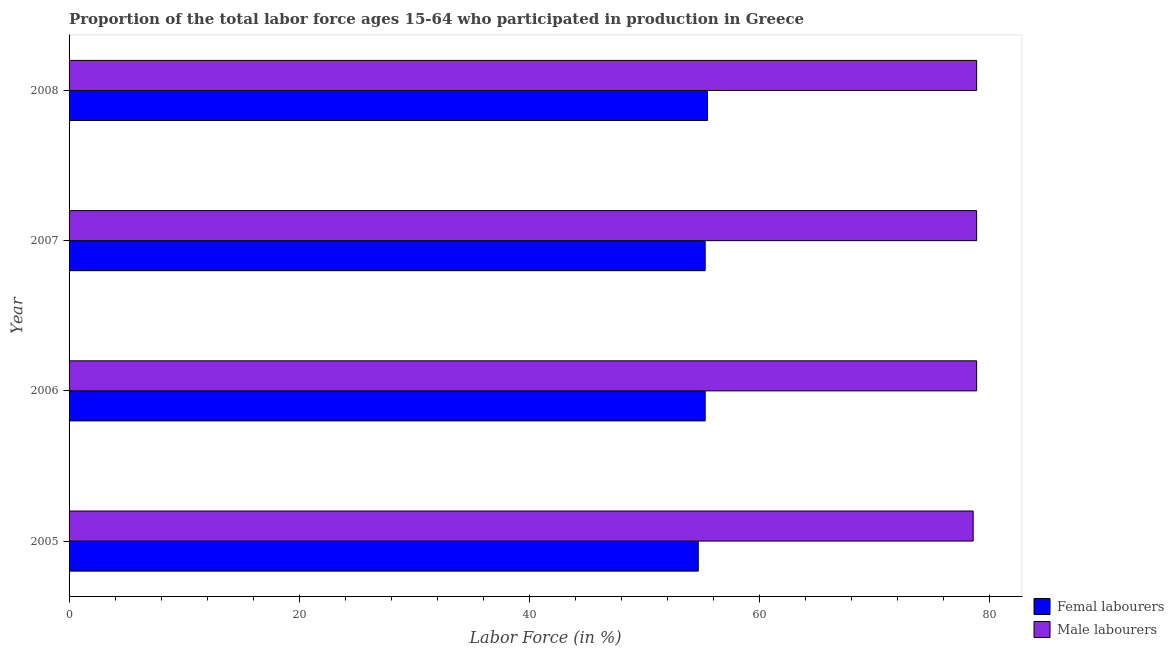How many groups of bars are there?
Offer a terse response. 4. Are the number of bars on each tick of the Y-axis equal?
Keep it short and to the point. Yes. In how many cases, is the number of bars for a given year not equal to the number of legend labels?
Provide a short and direct response. 0. What is the percentage of male labour force in 2006?
Give a very brief answer. 78.9. Across all years, what is the maximum percentage of female labor force?
Your response must be concise. 55.5. Across all years, what is the minimum percentage of male labour force?
Make the answer very short. 78.6. In which year was the percentage of female labor force maximum?
Provide a succinct answer. 2008. What is the total percentage of male labour force in the graph?
Provide a short and direct response. 315.3. What is the difference between the percentage of male labour force in 2007 and that in 2008?
Offer a terse response. 0. What is the difference between the percentage of female labor force in 2006 and the percentage of male labour force in 2008?
Your response must be concise. -23.6. What is the average percentage of male labour force per year?
Give a very brief answer. 78.83. In the year 2008, what is the difference between the percentage of male labour force and percentage of female labor force?
Keep it short and to the point. 23.4. What is the ratio of the percentage of female labor force in 2005 to that in 2007?
Your answer should be very brief. 0.99. Is the percentage of female labor force in 2005 less than that in 2006?
Your answer should be very brief. Yes. What is the difference between the highest and the lowest percentage of female labor force?
Provide a short and direct response. 0.8. In how many years, is the percentage of female labor force greater than the average percentage of female labor force taken over all years?
Your answer should be compact. 3. What does the 1st bar from the top in 2006 represents?
Offer a terse response. Male labourers. What does the 2nd bar from the bottom in 2006 represents?
Offer a very short reply. Male labourers. Are all the bars in the graph horizontal?
Your response must be concise. Yes. How many years are there in the graph?
Provide a succinct answer. 4. What is the difference between two consecutive major ticks on the X-axis?
Offer a terse response. 20. Does the graph contain grids?
Offer a very short reply. No. What is the title of the graph?
Provide a succinct answer. Proportion of the total labor force ages 15-64 who participated in production in Greece. Does "International Tourists" appear as one of the legend labels in the graph?
Provide a succinct answer. No. What is the Labor Force (in %) in Femal labourers in 2005?
Ensure brevity in your answer.  54.7. What is the Labor Force (in %) of Male labourers in 2005?
Provide a short and direct response. 78.6. What is the Labor Force (in %) in Femal labourers in 2006?
Your answer should be very brief. 55.3. What is the Labor Force (in %) in Male labourers in 2006?
Provide a succinct answer. 78.9. What is the Labor Force (in %) in Femal labourers in 2007?
Give a very brief answer. 55.3. What is the Labor Force (in %) in Male labourers in 2007?
Your answer should be very brief. 78.9. What is the Labor Force (in %) in Femal labourers in 2008?
Make the answer very short. 55.5. What is the Labor Force (in %) in Male labourers in 2008?
Provide a succinct answer. 78.9. Across all years, what is the maximum Labor Force (in %) of Femal labourers?
Give a very brief answer. 55.5. Across all years, what is the maximum Labor Force (in %) in Male labourers?
Make the answer very short. 78.9. Across all years, what is the minimum Labor Force (in %) in Femal labourers?
Your response must be concise. 54.7. Across all years, what is the minimum Labor Force (in %) of Male labourers?
Your answer should be very brief. 78.6. What is the total Labor Force (in %) in Femal labourers in the graph?
Offer a terse response. 220.8. What is the total Labor Force (in %) of Male labourers in the graph?
Offer a very short reply. 315.3. What is the difference between the Labor Force (in %) of Femal labourers in 2006 and that in 2008?
Offer a very short reply. -0.2. What is the difference between the Labor Force (in %) in Male labourers in 2006 and that in 2008?
Give a very brief answer. 0. What is the difference between the Labor Force (in %) in Femal labourers in 2007 and that in 2008?
Your response must be concise. -0.2. What is the difference between the Labor Force (in %) of Femal labourers in 2005 and the Labor Force (in %) of Male labourers in 2006?
Provide a short and direct response. -24.2. What is the difference between the Labor Force (in %) of Femal labourers in 2005 and the Labor Force (in %) of Male labourers in 2007?
Ensure brevity in your answer.  -24.2. What is the difference between the Labor Force (in %) of Femal labourers in 2005 and the Labor Force (in %) of Male labourers in 2008?
Offer a terse response. -24.2. What is the difference between the Labor Force (in %) of Femal labourers in 2006 and the Labor Force (in %) of Male labourers in 2007?
Give a very brief answer. -23.6. What is the difference between the Labor Force (in %) in Femal labourers in 2006 and the Labor Force (in %) in Male labourers in 2008?
Your response must be concise. -23.6. What is the difference between the Labor Force (in %) of Femal labourers in 2007 and the Labor Force (in %) of Male labourers in 2008?
Offer a terse response. -23.6. What is the average Labor Force (in %) of Femal labourers per year?
Make the answer very short. 55.2. What is the average Labor Force (in %) of Male labourers per year?
Provide a short and direct response. 78.83. In the year 2005, what is the difference between the Labor Force (in %) of Femal labourers and Labor Force (in %) of Male labourers?
Offer a very short reply. -23.9. In the year 2006, what is the difference between the Labor Force (in %) in Femal labourers and Labor Force (in %) in Male labourers?
Offer a very short reply. -23.6. In the year 2007, what is the difference between the Labor Force (in %) in Femal labourers and Labor Force (in %) in Male labourers?
Your response must be concise. -23.6. In the year 2008, what is the difference between the Labor Force (in %) of Femal labourers and Labor Force (in %) of Male labourers?
Give a very brief answer. -23.4. What is the ratio of the Labor Force (in %) in Femal labourers in 2005 to that in 2007?
Your response must be concise. 0.99. What is the ratio of the Labor Force (in %) in Male labourers in 2005 to that in 2007?
Offer a very short reply. 1. What is the ratio of the Labor Force (in %) of Femal labourers in 2005 to that in 2008?
Offer a terse response. 0.99. What is the ratio of the Labor Force (in %) in Male labourers in 2005 to that in 2008?
Your answer should be very brief. 1. What is the ratio of the Labor Force (in %) of Femal labourers in 2006 to that in 2007?
Your answer should be very brief. 1. What is the ratio of the Labor Force (in %) of Femal labourers in 2007 to that in 2008?
Make the answer very short. 1. What is the ratio of the Labor Force (in %) in Male labourers in 2007 to that in 2008?
Make the answer very short. 1. 